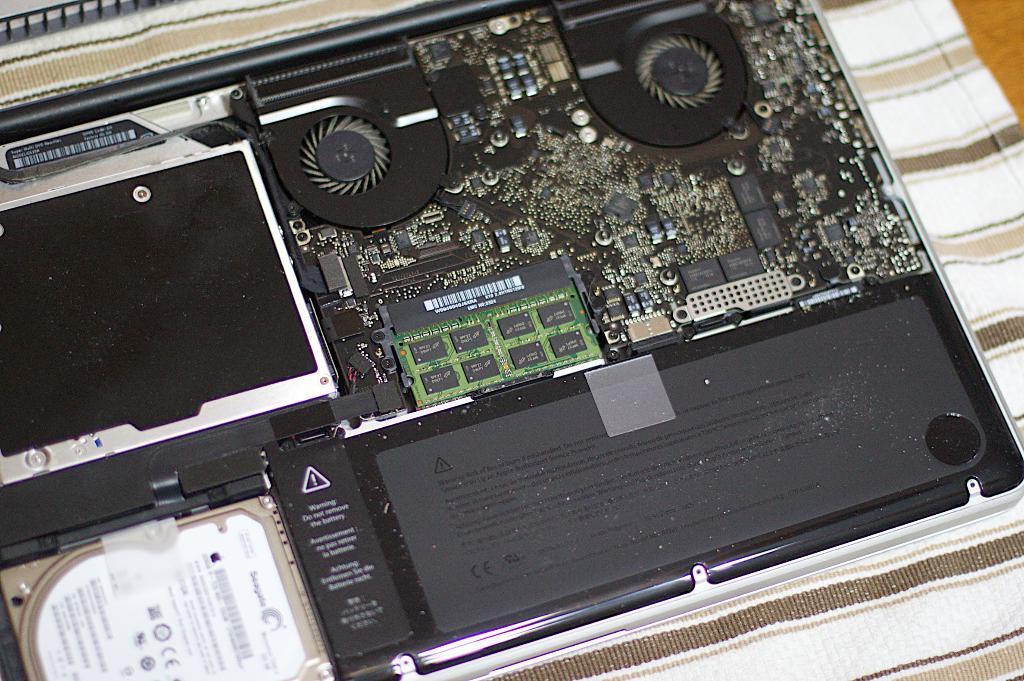Is that a hard disk?
Your answer should be very brief. Answering does not require reading text in the image. Does it say warning under the symbol?
Keep it short and to the point. Yes. 